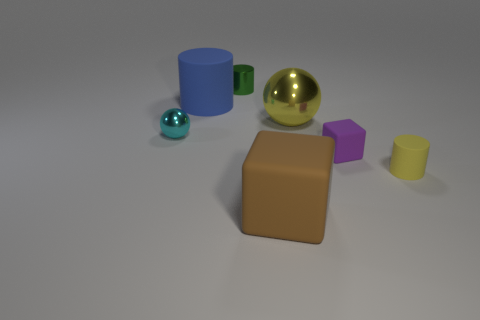Subtract all rubber cylinders. How many cylinders are left? 1 Add 1 small gray things. How many objects exist? 8 Subtract all brown blocks. How many blocks are left? 1 Subtract all balls. How many objects are left? 5 Subtract all purple balls. Subtract all gray cylinders. How many balls are left? 2 Subtract all purple cubes. How many purple cylinders are left? 0 Subtract all small blue shiny things. Subtract all big things. How many objects are left? 4 Add 5 metal cylinders. How many metal cylinders are left? 6 Add 2 tiny cylinders. How many tiny cylinders exist? 4 Subtract 1 cyan balls. How many objects are left? 6 